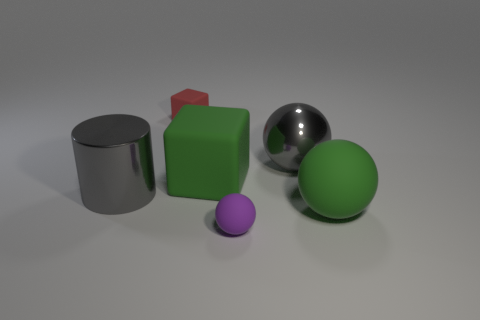There is a large thing that is the same color as the shiny sphere; what is its material?
Your response must be concise. Metal. There is a big thing that is left of the big green matte cube; what color is it?
Give a very brief answer. Gray. What number of other objects are the same material as the small block?
Make the answer very short. 3. Is the number of big gray metallic cylinders that are behind the tiny purple rubber object greater than the number of big green things that are to the left of the large cylinder?
Offer a terse response. Yes. How many metal balls are to the right of the tiny block?
Give a very brief answer. 1. Are the cylinder and the gray object that is right of the green block made of the same material?
Your response must be concise. Yes. Is there anything else that is the same shape as the small red object?
Your answer should be compact. Yes. Are the tiny purple thing and the big gray sphere made of the same material?
Keep it short and to the point. No. Is there a small red matte thing that is in front of the tiny object that is in front of the tiny rubber block?
Make the answer very short. No. What number of metal objects are both on the left side of the tiny red rubber object and to the right of the tiny purple ball?
Your answer should be very brief. 0. 